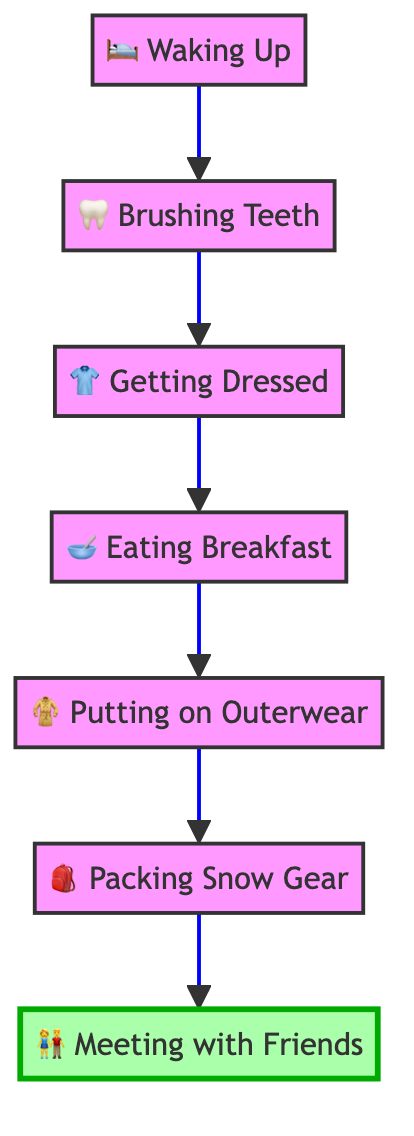What is the first step in the morning routine? The diagram shows that the first node is "Waking Up," indicating the starting point of the morning routine.
Answer: Waking Up How many nodes are in the diagram? There are seven nodes representing different steps in the morning routine: Waking Up, Brushing Teeth, Getting Dressed, Eating Breakfast, Putting on Outerwear, Packing Snow Gear, and Meeting with Friends.
Answer: Seven What comes after "Brushing Teeth"? The flow of the diagram indicates that after "Brushing Teeth," the next step is "Getting Dressed."
Answer: Getting Dressed Which activity is the last step before meeting friends? The diagram shows the last activity before "Meeting with Friends" is "Packing Snow Gear." This is the step where important items are prepared for the snow day.
Answer: Packing Snow Gear What type of clothing is included in "Getting Dressed"? According to the description for "Getting Dressed" in the diagram, it includes thermal underwear, a sweater, snow pants, socks, and waterproof boots.
Answer: Warm clothes Which activity includes breakfast? The node "Eating Breakfast" specifically refers to the activity where the child has a nutritious breakfast, indicating this is the step focused on meal consumption.
Answer: Eating Breakfast What gear is packed in "Packing Snow Gear"? The description in the diagram specifies that "Packing Snow Gear" includes sleds, mittens, and extra socks as essential items for a snow day.
Answer: Sleds, mittens, and extra socks What item is needed before going to meet friends? Before "Meeting with Friends," the diagram shows that "Packing Snow Gear" is essential; this step prepares the child with necessary items for fun snow activities.
Answer: Packing Snow Gear What is the flow direction of the diagram? The diagram clearly points upward from the starting step of "Waking Up" to the final step of "Meeting with Friends," indicating that the flow of activity progresses in an upward direction.
Answer: Upward 